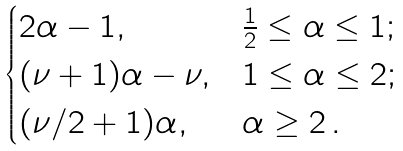<formula> <loc_0><loc_0><loc_500><loc_500>\begin{cases} 2 \alpha - 1 , & \frac { 1 } { 2 } \leq \alpha \leq 1 ; \\ ( \nu + 1 ) \alpha - \nu , & 1 \leq \alpha \leq 2 ; \\ ( \nu / 2 + 1 ) \alpha , & \alpha \geq 2 \, . \end{cases}</formula> 